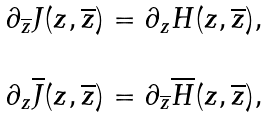<formula> <loc_0><loc_0><loc_500><loc_500>\begin{array} { l } \partial _ { \overline { z } } J ( z , \overline { z } ) = \partial _ { z } H ( z , \overline { z } ) , \\ \\ \partial _ { z } \overline { J } ( z , \overline { z } ) = \partial _ { \overline { z } } \overline { H } ( z , \overline { z } ) , \end{array}</formula> 